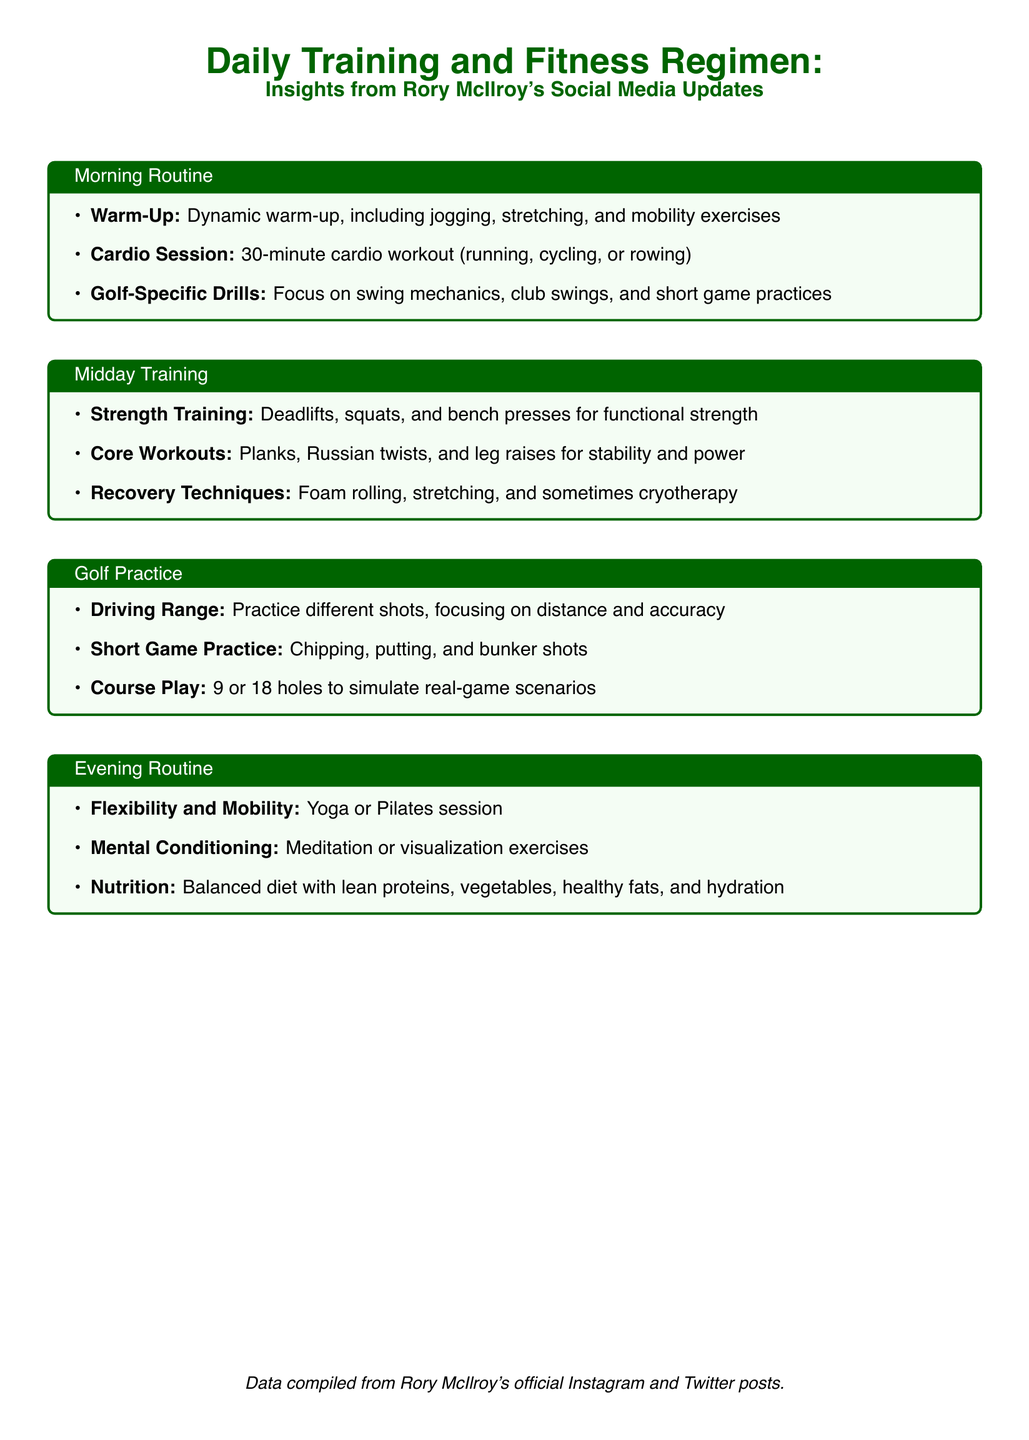What is included in Rory McIlroy's warm-up routine? The warm-up routine consists of dynamic warm-up, including jogging, stretching, and mobility exercises.
Answer: dynamic warm-up, including jogging, stretching, and mobility exercises How long is the cardio session in the morning routine? The morning cardio session is specified to be 30 minutes long.
Answer: 30 minutes What types of exercises are part of the strength training regimen? The strength training includes deadlifts, squats, and bench presses for functional strength.
Answer: deadlifts, squats, and bench presses Which recovery techniques are mentioned in the midday training section? The recovery techniques include foam rolling, stretching, and sometimes cryotherapy.
Answer: foam rolling, stretching, and sometimes cryotherapy What component of the evening routine focuses on mental fitness? The evening routine includes mental conditioning activities like meditation or visualization exercises.
Answer: meditation or visualization exercises What does Rory practice at the driving range? At the driving range, Rory practices different shots, focusing on distance and accuracy.
Answer: different shots, focusing on distance and accuracy What type of diet does Rory McIlroy follow in his evening routine? The evening routine mentions a balanced diet with lean proteins, vegetables, healthy fats, and hydration.
Answer: balanced diet with lean proteins, vegetables, healthy fats, and hydration How often does Rory McIlroy play 9 or 18 holes? Playing 9 or 18 holes is part of his routine to simulate real-game scenarios which suggests a regular practice.
Answer: regularly 